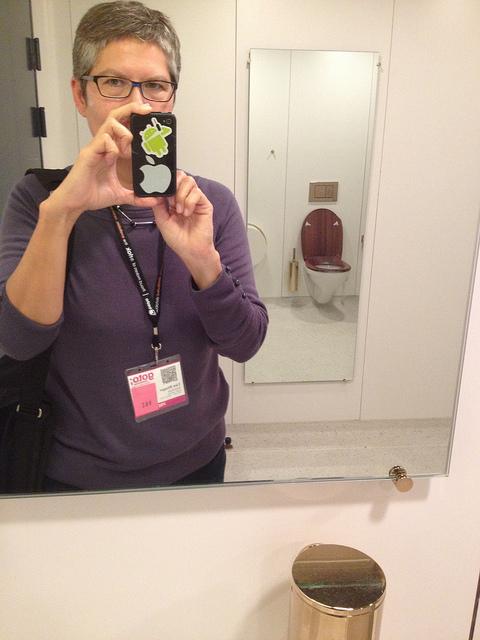Where is the Android sticker?
Be succinct. On phone. What is being used to take a picture?
Be succinct. Cell phone. How many mirrors can be seen?
Quick response, please. 2. 